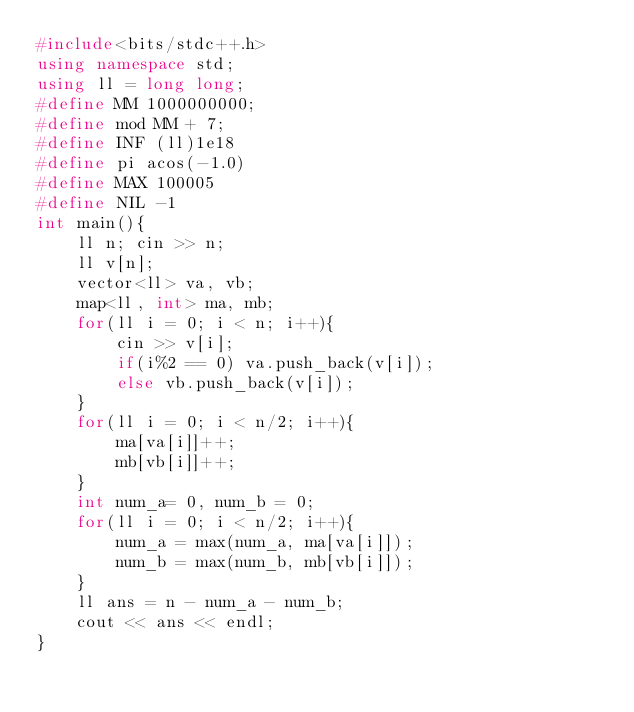Convert code to text. <code><loc_0><loc_0><loc_500><loc_500><_C++_>#include<bits/stdc++.h>
using namespace std;
using ll = long long;
#define MM 1000000000;
#define mod MM + 7;
#define INF (ll)1e18
#define pi acos(-1.0)
#define MAX 100005
#define NIL -1
int main(){
    ll n; cin >> n;
    ll v[n];
    vector<ll> va, vb;
    map<ll, int> ma, mb;
    for(ll i = 0; i < n; i++){
        cin >> v[i];
        if(i%2 == 0) va.push_back(v[i]);
        else vb.push_back(v[i]);
    }
    for(ll i = 0; i < n/2; i++){
        ma[va[i]]++;
        mb[vb[i]]++;
    }
    int num_a= 0, num_b = 0;
    for(ll i = 0; i < n/2; i++){
        num_a = max(num_a, ma[va[i]]);
        num_b = max(num_b, mb[vb[i]]);
    }
    ll ans = n - num_a - num_b;
    cout << ans << endl;
}</code> 